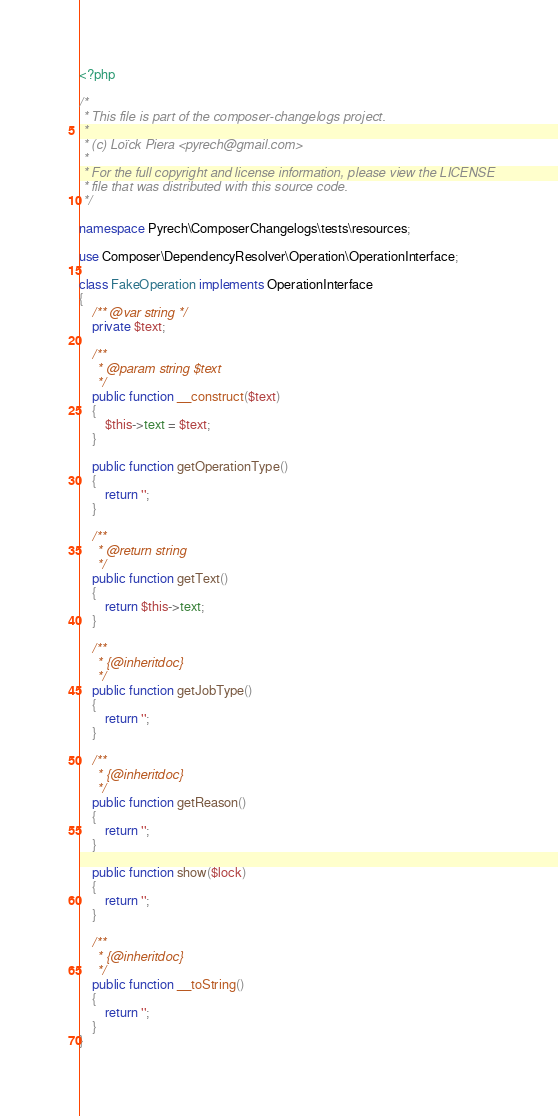Convert code to text. <code><loc_0><loc_0><loc_500><loc_500><_PHP_><?php

/*
 * This file is part of the composer-changelogs project.
 *
 * (c) Loïck Piera <pyrech@gmail.com>
 *
 * For the full copyright and license information, please view the LICENSE
 * file that was distributed with this source code.
 */

namespace Pyrech\ComposerChangelogs\tests\resources;

use Composer\DependencyResolver\Operation\OperationInterface;

class FakeOperation implements OperationInterface
{
    /** @var string */
    private $text;

    /**
     * @param string $text
     */
    public function __construct($text)
    {
        $this->text = $text;
    }

    public function getOperationType()
    {
        return '';
    }

    /**
     * @return string
     */
    public function getText()
    {
        return $this->text;
    }

    /**
     * {@inheritdoc}
     */
    public function getJobType()
    {
        return '';
    }

    /**
     * {@inheritdoc}
     */
    public function getReason()
    {
        return '';
    }

    public function show($lock)
    {
        return '';
    }

    /**
     * {@inheritdoc}
     */
    public function __toString()
    {
        return '';
    }
}
</code> 